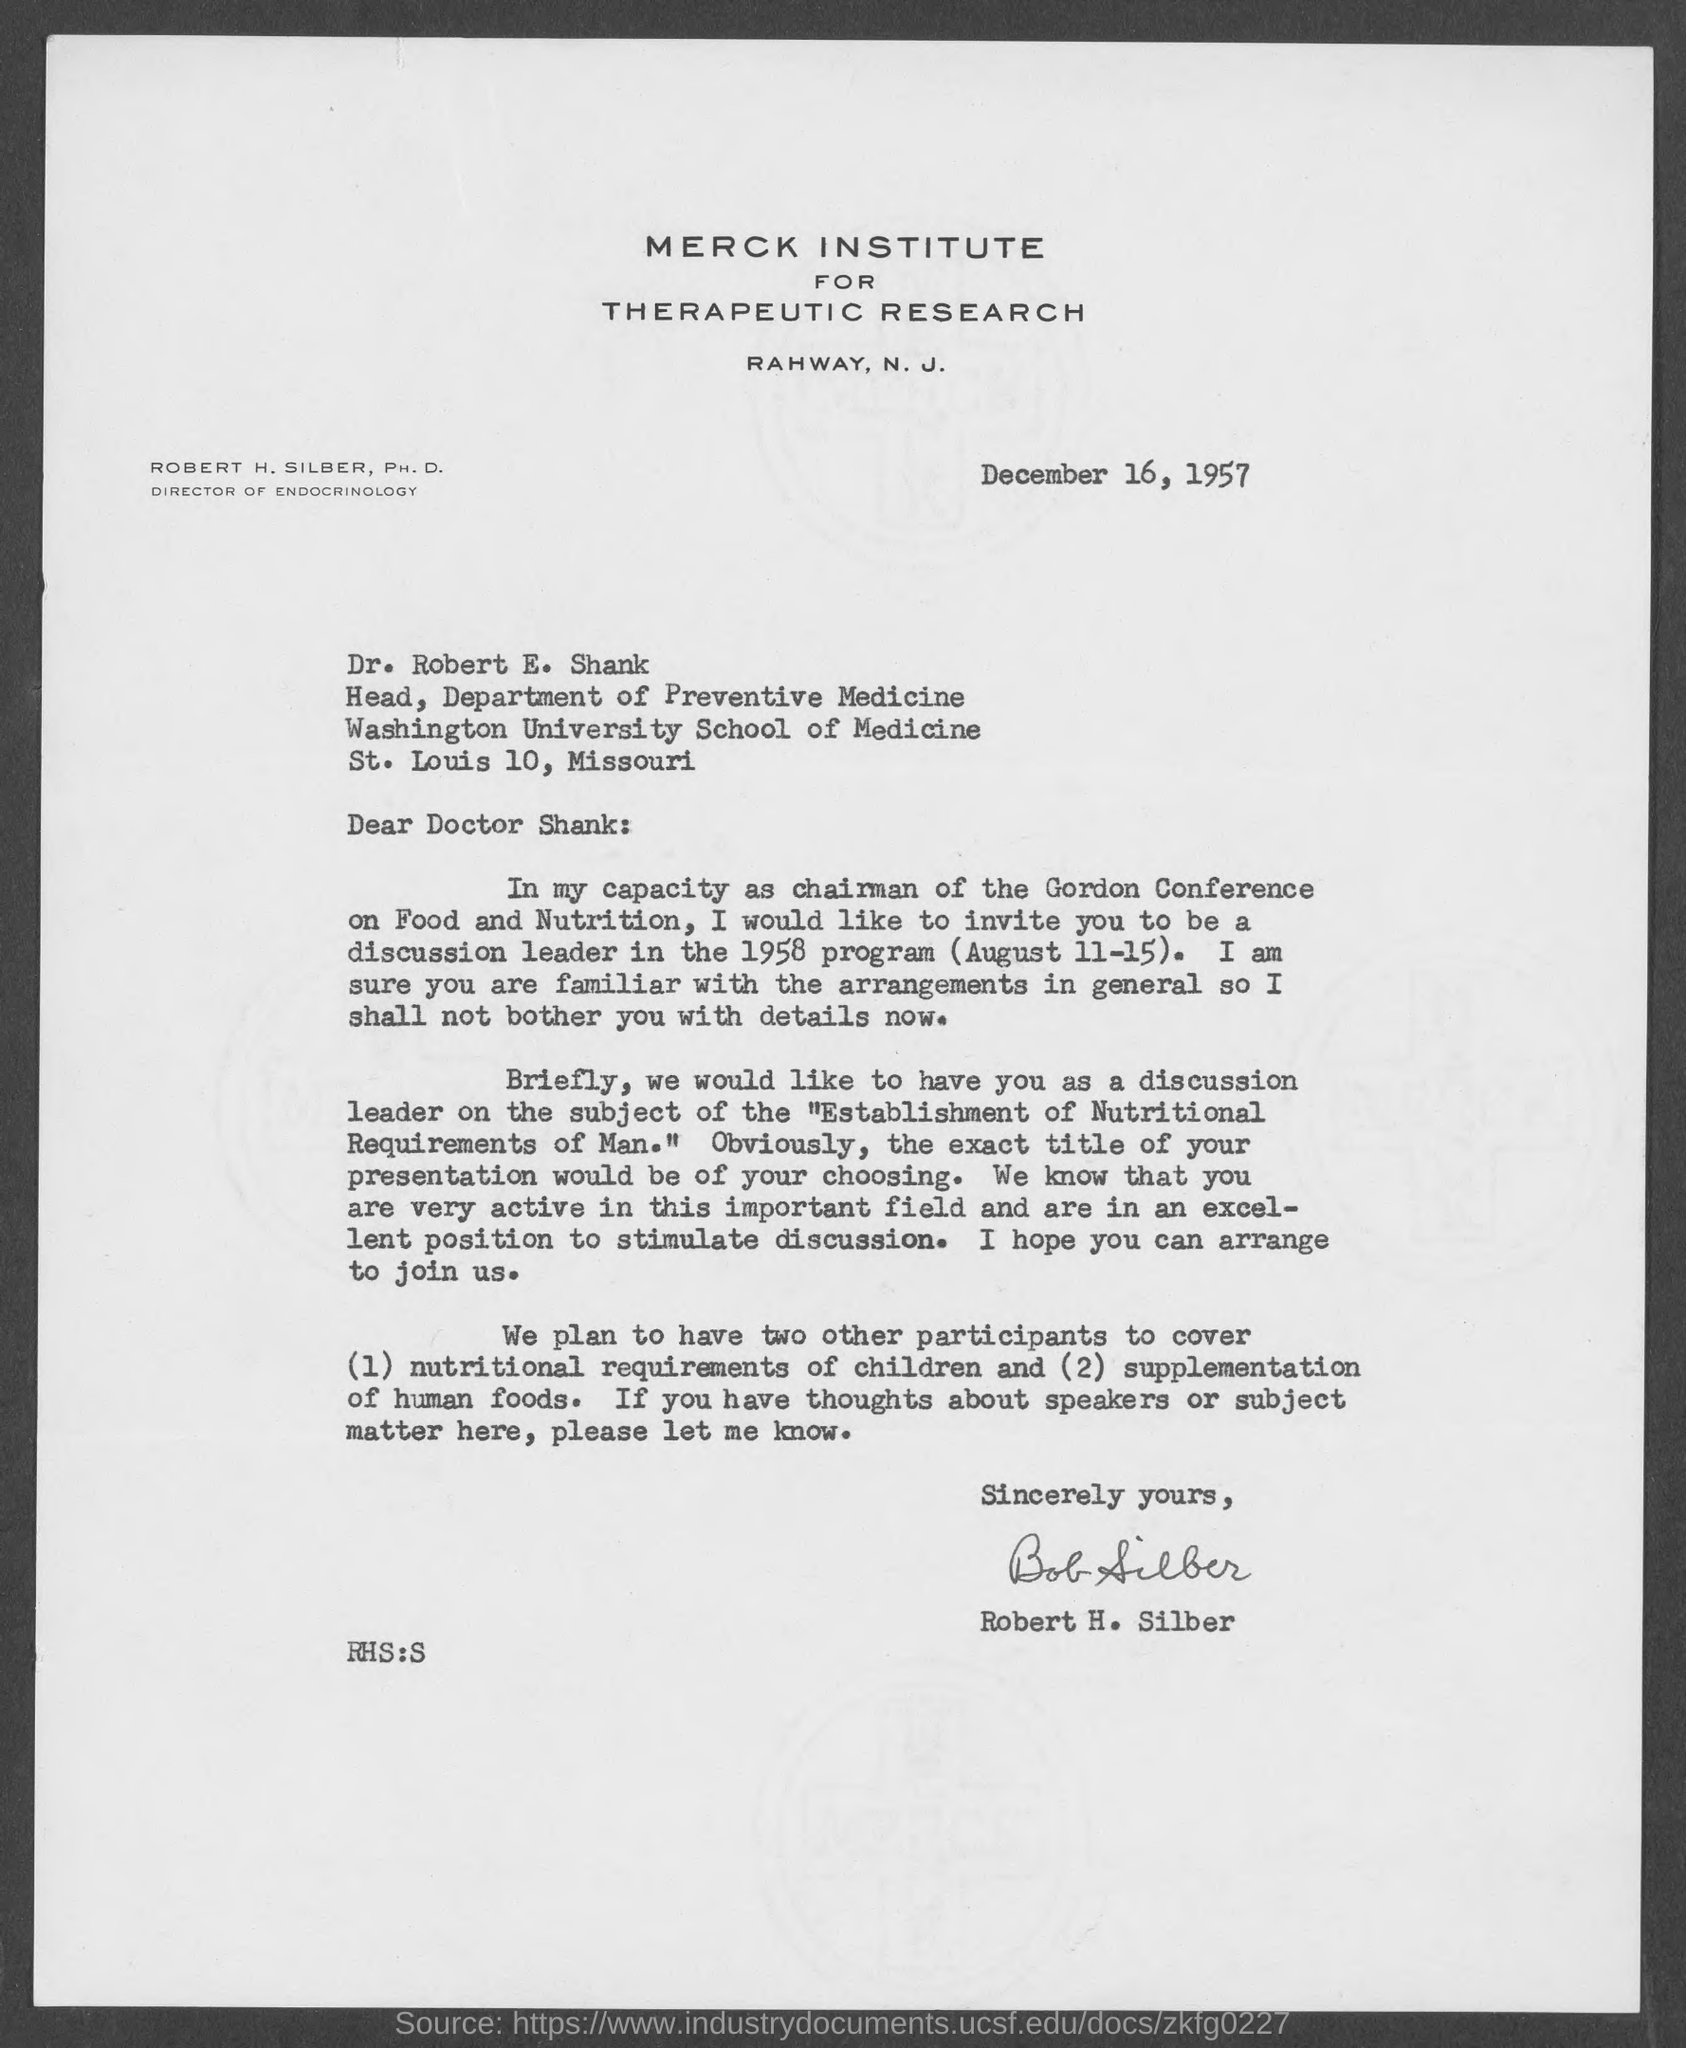Which institute is mentioned in the letterhead?
Your answer should be very brief. Merck Institute for Therapeutic Research. What is the issued date of this letter?
Make the answer very short. December 16, 1957. Who has signed this letter?
Ensure brevity in your answer.  Robert H. Silber. 